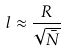<formula> <loc_0><loc_0><loc_500><loc_500>l \approx \frac { R } { \sqrt { \bar { N } } }</formula> 